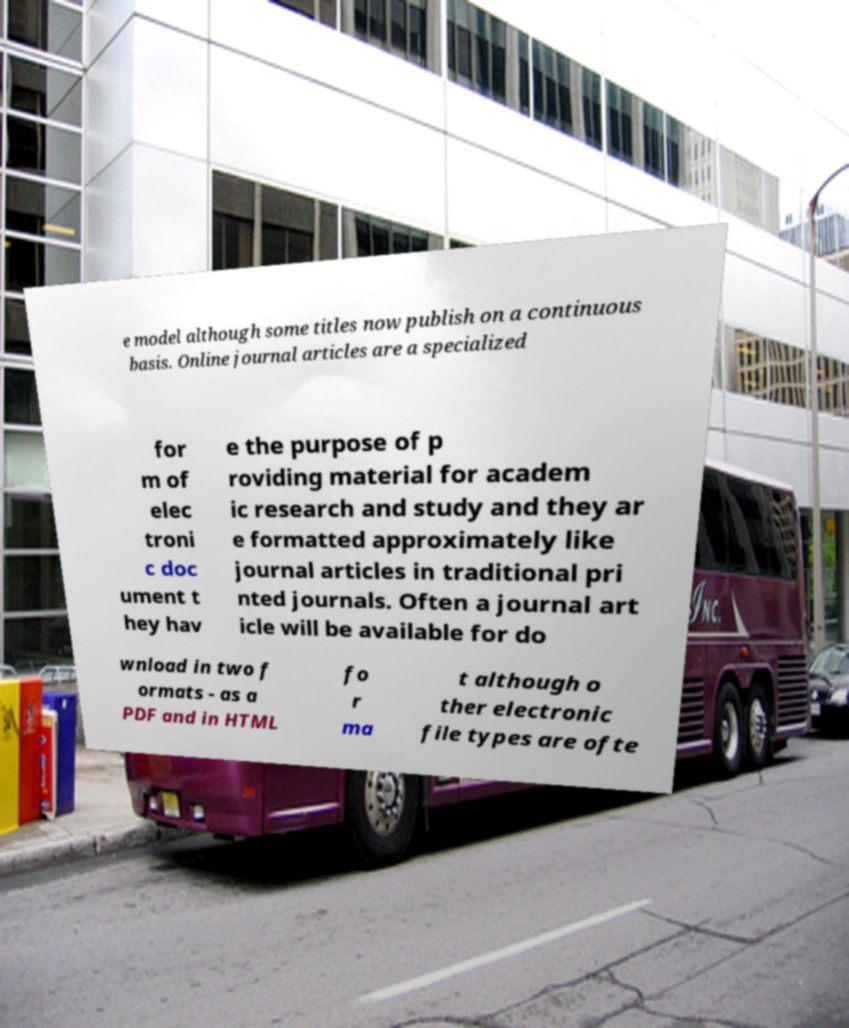For documentation purposes, I need the text within this image transcribed. Could you provide that? e model although some titles now publish on a continuous basis. Online journal articles are a specialized for m of elec troni c doc ument t hey hav e the purpose of p roviding material for academ ic research and study and they ar e formatted approximately like journal articles in traditional pri nted journals. Often a journal art icle will be available for do wnload in two f ormats - as a PDF and in HTML fo r ma t although o ther electronic file types are ofte 